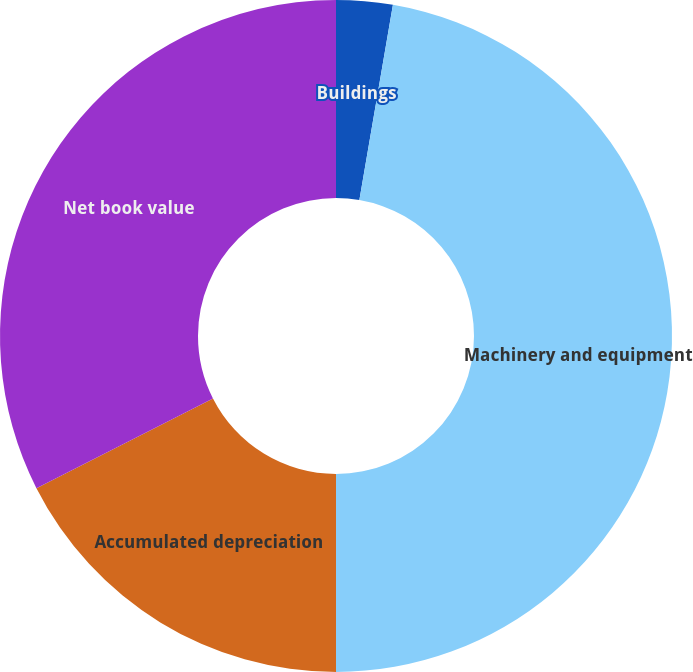Convert chart. <chart><loc_0><loc_0><loc_500><loc_500><pie_chart><fcel>Buildings<fcel>Machinery and equipment<fcel>Accumulated depreciation<fcel>Net book value<nl><fcel>2.71%<fcel>47.29%<fcel>17.52%<fcel>32.48%<nl></chart> 